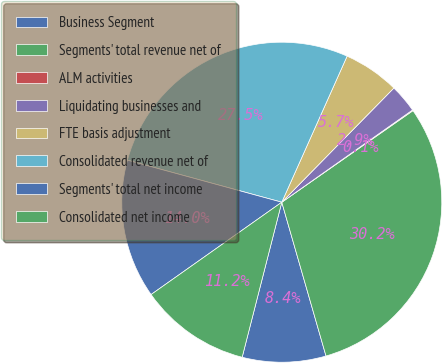<chart> <loc_0><loc_0><loc_500><loc_500><pie_chart><fcel>Business Segment<fcel>Segments' total revenue net of<fcel>ALM activities<fcel>Liquidating businesses and<fcel>FTE basis adjustment<fcel>Consolidated revenue net of<fcel>Segments' total net income<fcel>Consolidated net income<nl><fcel>8.44%<fcel>30.24%<fcel>0.08%<fcel>2.87%<fcel>5.66%<fcel>27.46%<fcel>14.02%<fcel>11.23%<nl></chart> 